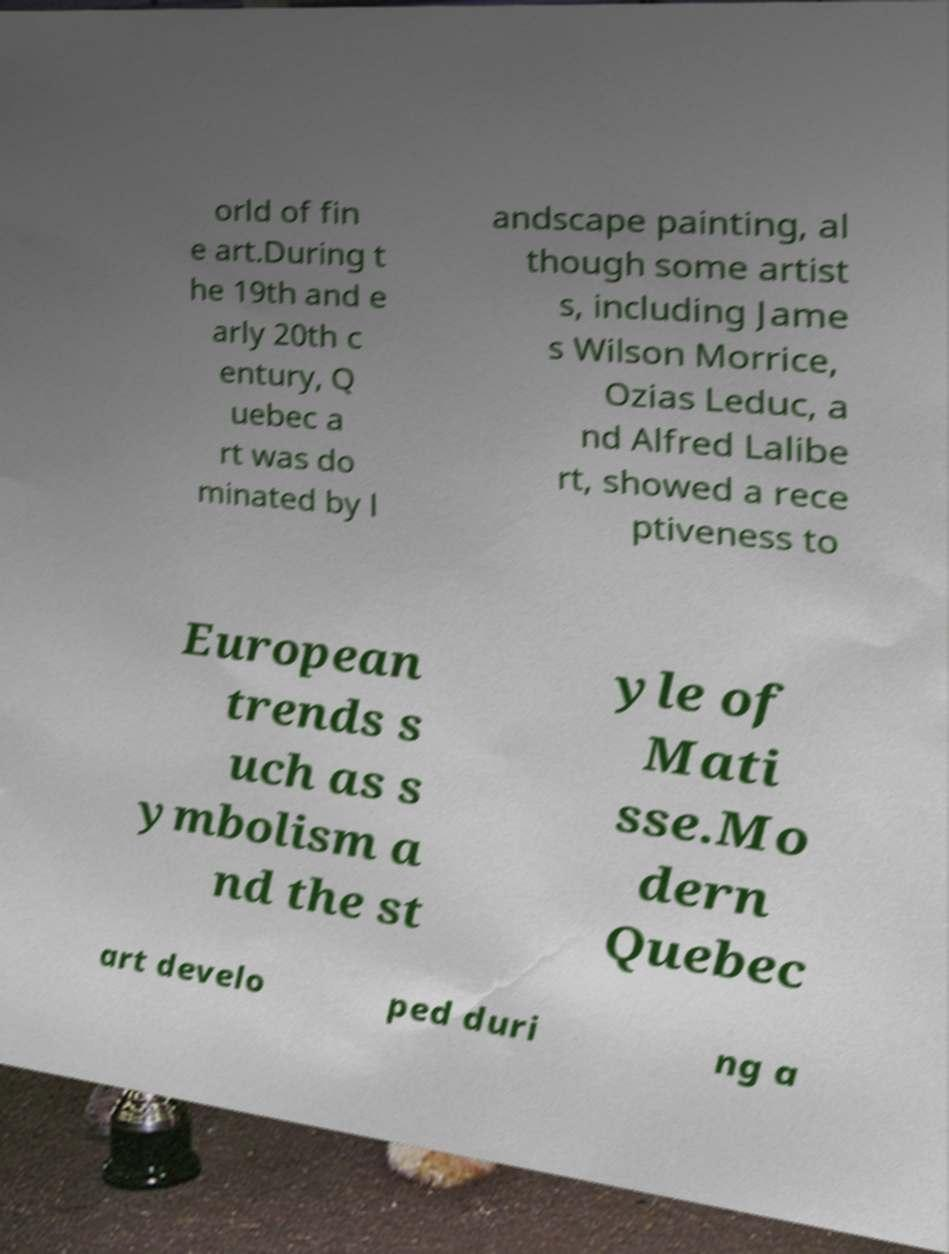Can you accurately transcribe the text from the provided image for me? orld of fin e art.During t he 19th and e arly 20th c entury, Q uebec a rt was do minated by l andscape painting, al though some artist s, including Jame s Wilson Morrice, Ozias Leduc, a nd Alfred Lalibe rt, showed a rece ptiveness to European trends s uch as s ymbolism a nd the st yle of Mati sse.Mo dern Quebec art develo ped duri ng a 